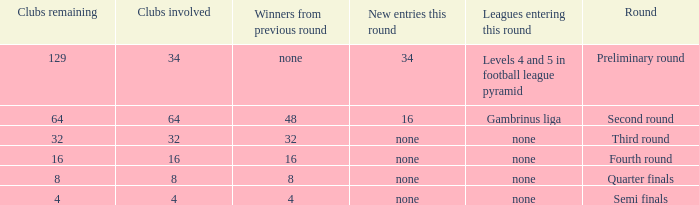Name the least clubs involved for leagues being none for semi finals 4.0. 